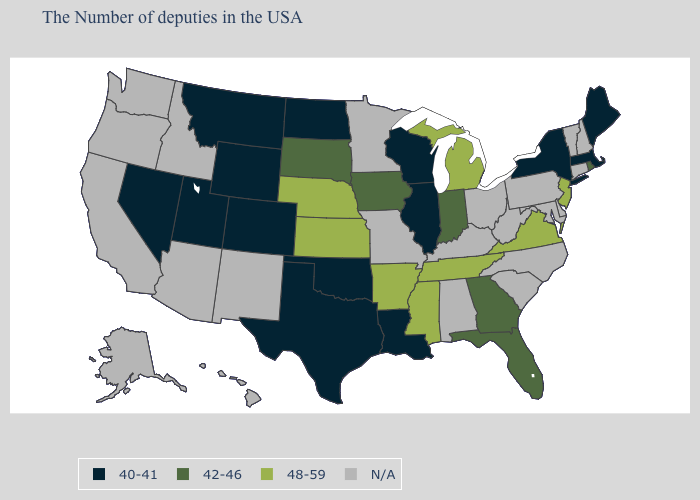Name the states that have a value in the range 48-59?
Short answer required. New Jersey, Virginia, Michigan, Tennessee, Mississippi, Arkansas, Kansas, Nebraska. What is the value of Florida?
Give a very brief answer. 42-46. What is the value of Missouri?
Keep it brief. N/A. Name the states that have a value in the range N/A?
Answer briefly. New Hampshire, Vermont, Connecticut, Delaware, Maryland, Pennsylvania, North Carolina, South Carolina, West Virginia, Ohio, Kentucky, Alabama, Missouri, Minnesota, New Mexico, Arizona, Idaho, California, Washington, Oregon, Alaska, Hawaii. What is the highest value in the Northeast ?
Concise answer only. 48-59. What is the value of Texas?
Quick response, please. 40-41. Name the states that have a value in the range N/A?
Quick response, please. New Hampshire, Vermont, Connecticut, Delaware, Maryland, Pennsylvania, North Carolina, South Carolina, West Virginia, Ohio, Kentucky, Alabama, Missouri, Minnesota, New Mexico, Arizona, Idaho, California, Washington, Oregon, Alaska, Hawaii. What is the value of Colorado?
Answer briefly. 40-41. What is the value of Arkansas?
Answer briefly. 48-59. Does Iowa have the highest value in the MidWest?
Keep it brief. No. Name the states that have a value in the range N/A?
Be succinct. New Hampshire, Vermont, Connecticut, Delaware, Maryland, Pennsylvania, North Carolina, South Carolina, West Virginia, Ohio, Kentucky, Alabama, Missouri, Minnesota, New Mexico, Arizona, Idaho, California, Washington, Oregon, Alaska, Hawaii. What is the value of Utah?
Quick response, please. 40-41. Does Mississippi have the highest value in the USA?
Write a very short answer. Yes. Which states have the highest value in the USA?
Short answer required. New Jersey, Virginia, Michigan, Tennessee, Mississippi, Arkansas, Kansas, Nebraska. 